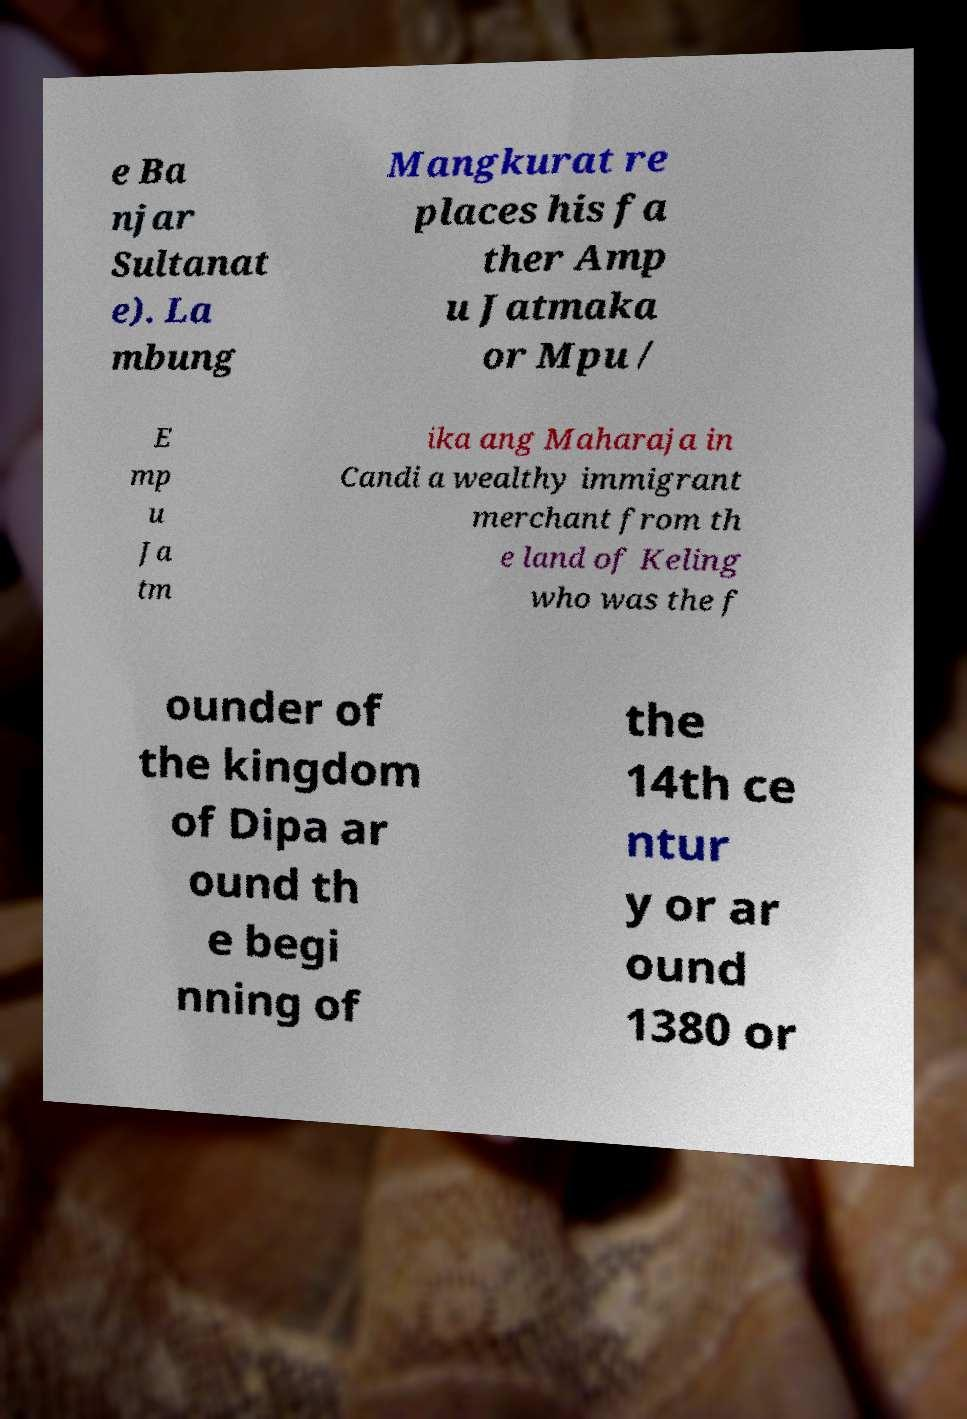Please identify and transcribe the text found in this image. e Ba njar Sultanat e). La mbung Mangkurat re places his fa ther Amp u Jatmaka or Mpu / E mp u Ja tm ika ang Maharaja in Candi a wealthy immigrant merchant from th e land of Keling who was the f ounder of the kingdom of Dipa ar ound th e begi nning of the 14th ce ntur y or ar ound 1380 or 